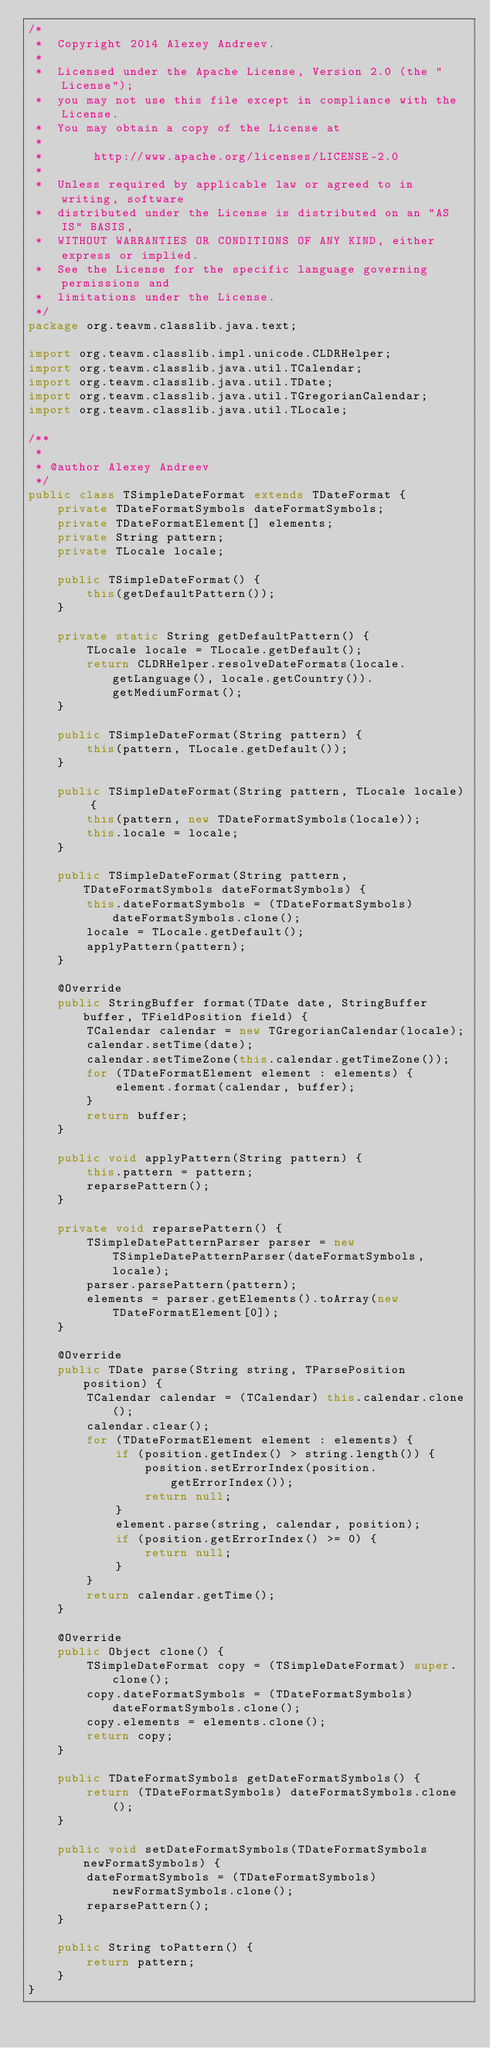<code> <loc_0><loc_0><loc_500><loc_500><_Java_>/*
 *  Copyright 2014 Alexey Andreev.
 *
 *  Licensed under the Apache License, Version 2.0 (the "License");
 *  you may not use this file except in compliance with the License.
 *  You may obtain a copy of the License at
 *
 *       http://www.apache.org/licenses/LICENSE-2.0
 *
 *  Unless required by applicable law or agreed to in writing, software
 *  distributed under the License is distributed on an "AS IS" BASIS,
 *  WITHOUT WARRANTIES OR CONDITIONS OF ANY KIND, either express or implied.
 *  See the License for the specific language governing permissions and
 *  limitations under the License.
 */
package org.teavm.classlib.java.text;

import org.teavm.classlib.impl.unicode.CLDRHelper;
import org.teavm.classlib.java.util.TCalendar;
import org.teavm.classlib.java.util.TDate;
import org.teavm.classlib.java.util.TGregorianCalendar;
import org.teavm.classlib.java.util.TLocale;

/**
 *
 * @author Alexey Andreev
 */
public class TSimpleDateFormat extends TDateFormat {
    private TDateFormatSymbols dateFormatSymbols;
    private TDateFormatElement[] elements;
    private String pattern;
    private TLocale locale;

    public TSimpleDateFormat() {
        this(getDefaultPattern());
    }

    private static String getDefaultPattern() {
        TLocale locale = TLocale.getDefault();
        return CLDRHelper.resolveDateFormats(locale.getLanguage(), locale.getCountry()).getMediumFormat();
    }

    public TSimpleDateFormat(String pattern) {
        this(pattern, TLocale.getDefault());
    }

    public TSimpleDateFormat(String pattern, TLocale locale) {
        this(pattern, new TDateFormatSymbols(locale));
        this.locale = locale;
    }

    public TSimpleDateFormat(String pattern, TDateFormatSymbols dateFormatSymbols) {
        this.dateFormatSymbols = (TDateFormatSymbols) dateFormatSymbols.clone();
        locale = TLocale.getDefault();
        applyPattern(pattern);
    }

    @Override
    public StringBuffer format(TDate date, StringBuffer buffer, TFieldPosition field) {
        TCalendar calendar = new TGregorianCalendar(locale);
        calendar.setTime(date);
        calendar.setTimeZone(this.calendar.getTimeZone());
        for (TDateFormatElement element : elements) {
            element.format(calendar, buffer);
        }
        return buffer;
    }

    public void applyPattern(String pattern) {
        this.pattern = pattern;
        reparsePattern();
    }

    private void reparsePattern() {
        TSimpleDatePatternParser parser = new TSimpleDatePatternParser(dateFormatSymbols, locale);
        parser.parsePattern(pattern);
        elements = parser.getElements().toArray(new TDateFormatElement[0]);
    }

    @Override
    public TDate parse(String string, TParsePosition position) {
        TCalendar calendar = (TCalendar) this.calendar.clone();
        calendar.clear();
        for (TDateFormatElement element : elements) {
            if (position.getIndex() > string.length()) {
                position.setErrorIndex(position.getErrorIndex());
                return null;
            }
            element.parse(string, calendar, position);
            if (position.getErrorIndex() >= 0) {
                return null;
            }
        }
        return calendar.getTime();
    }

    @Override
    public Object clone() {
        TSimpleDateFormat copy = (TSimpleDateFormat) super.clone();
        copy.dateFormatSymbols = (TDateFormatSymbols) dateFormatSymbols.clone();
        copy.elements = elements.clone();
        return copy;
    }

    public TDateFormatSymbols getDateFormatSymbols() {
        return (TDateFormatSymbols) dateFormatSymbols.clone();
    }

    public void setDateFormatSymbols(TDateFormatSymbols newFormatSymbols) {
        dateFormatSymbols = (TDateFormatSymbols) newFormatSymbols.clone();
        reparsePattern();
    }

    public String toPattern() {
        return pattern;
    }
}
</code> 